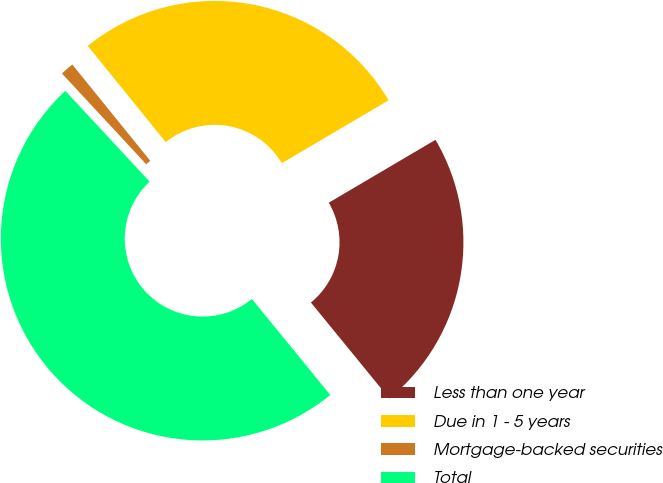Convert chart to OTSL. <chart><loc_0><loc_0><loc_500><loc_500><pie_chart><fcel>Less than one year<fcel>Due in 1 - 5 years<fcel>Mortgage-backed securities<fcel>Total<nl><fcel>22.57%<fcel>27.36%<fcel>1.08%<fcel>48.99%<nl></chart> 